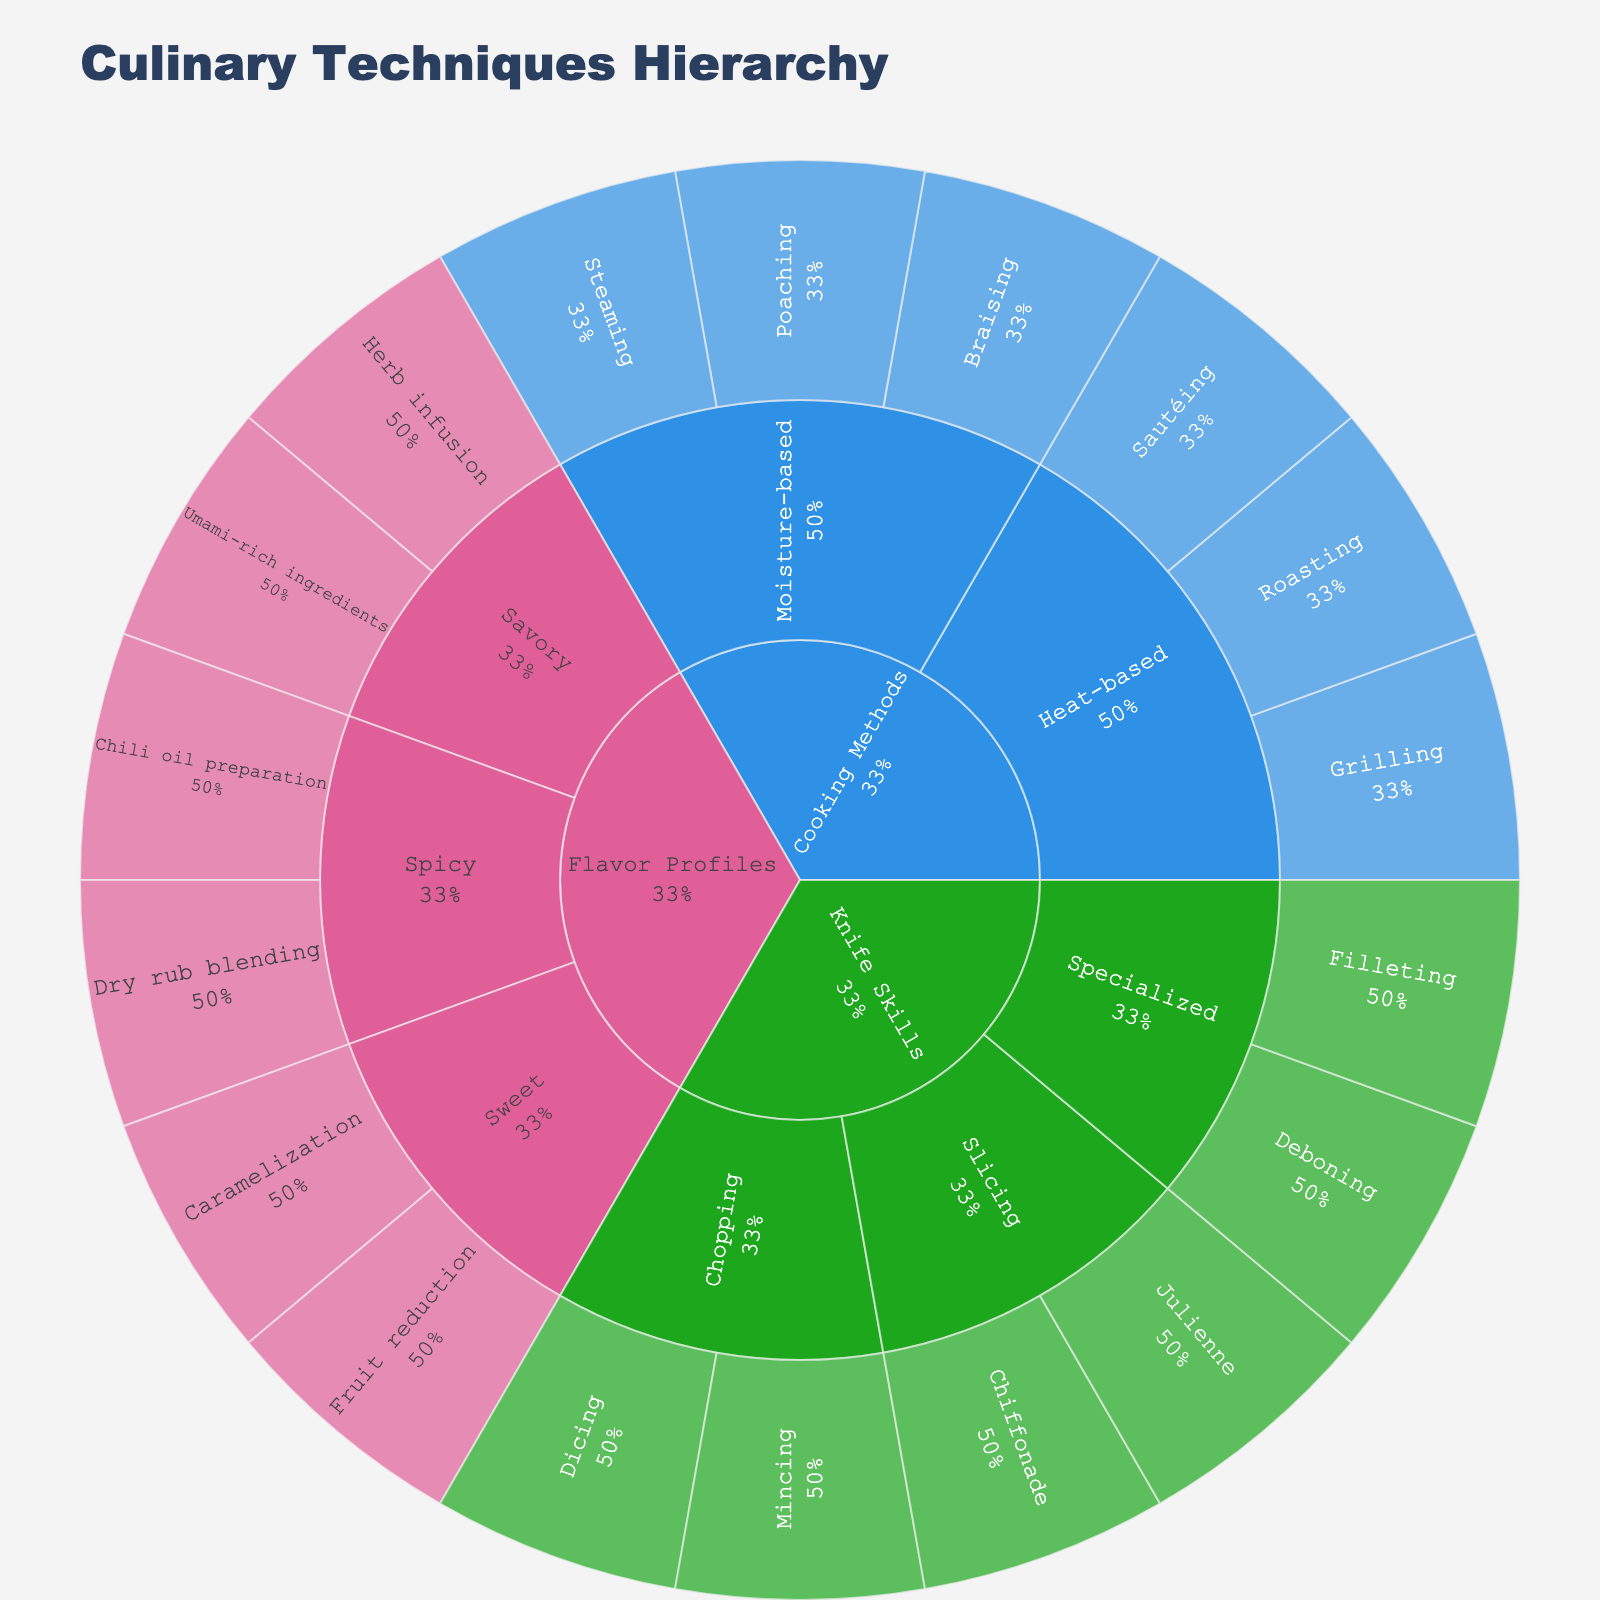What is the title of the plot? The title of the plot is shown at the top and usually summarizes the main content of the plot. In this case, it indicates the hierarchy of culinary techniques.
Answer: Culinary Techniques Hierarchy How many subcategories are under "Cooking Methods"? To find this, you need to look at the subdivisions branching out from the "Cooking Methods" category.
Answer: Two Which subcategory under "Knife Skills" has more techniques? Compare the number of techniques under each subcategory of "Knife Skills", namely "Chopping," "Slicing," and "Specialized," to determine which has more techniques.
Answer: Chopping What percentage of the "Flavor Profiles" category does "Sweet" cover? Look at the visual representation of the percentage coverage of "Sweet" within the "Flavor Profiles" category in the sunburst plot.
Answer: 40% Which "Flavor Profiles" subcategory contains "Chili oil preparation"? Find the subcategories under "Flavor Profiles" and locate which one contains the specific technique "Chili oil preparation".
Answer: Spicy Which has more techniques: "Heat-based" cooking methods or "Moisture-based" cooking methods? Sum up the techniques listed under each subcategory of "Cooking Methods" and compare the totals.
Answer: Heat-based What are the techniques listed under "Specialized" knife skills? Explore the hierarchical branches for "Knife Skills" and identify the techniques listed under the "Specialized" subcategory.
Answer: Filleting, Deboning Which subcategory contains the "Herb infusion" technique? Follow the hierarchical path to find the specific subcategory under "Flavor Profiles" that includes the "Herb infusion" technique.
Answer: Savory What percentage does "Steaming" represent within the "Moisture-based" cooking methods? Examine the visual segment for "Steaming" within the "Moisture-based" subcategory to determine its percentage coverage.
Answer: 33.3% What are the two subcategories under "Sweet" in Flavor Profiles? Locate the branch extending from the "Flavor Profiles" category and identify the subcategories under "Sweet".
Answer: Caramelization, Fruit reduction 